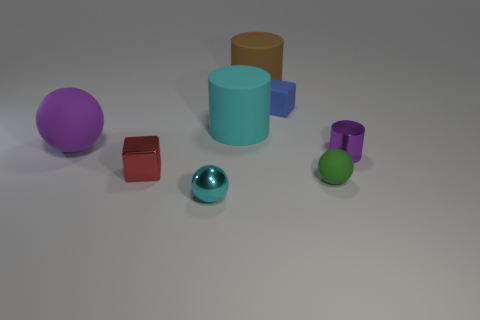Add 1 cyan rubber cubes. How many objects exist? 9 Subtract all brown cylinders. How many cylinders are left? 2 Subtract all brown cylinders. How many cylinders are left? 2 Subtract 1 cubes. How many cubes are left? 1 Subtract all purple balls. Subtract all yellow cubes. How many balls are left? 2 Subtract all blue spheres. How many cyan blocks are left? 0 Subtract all large matte balls. Subtract all yellow metallic blocks. How many objects are left? 7 Add 3 red metallic things. How many red metallic things are left? 4 Add 6 big purple matte balls. How many big purple matte balls exist? 7 Subtract 0 gray spheres. How many objects are left? 8 